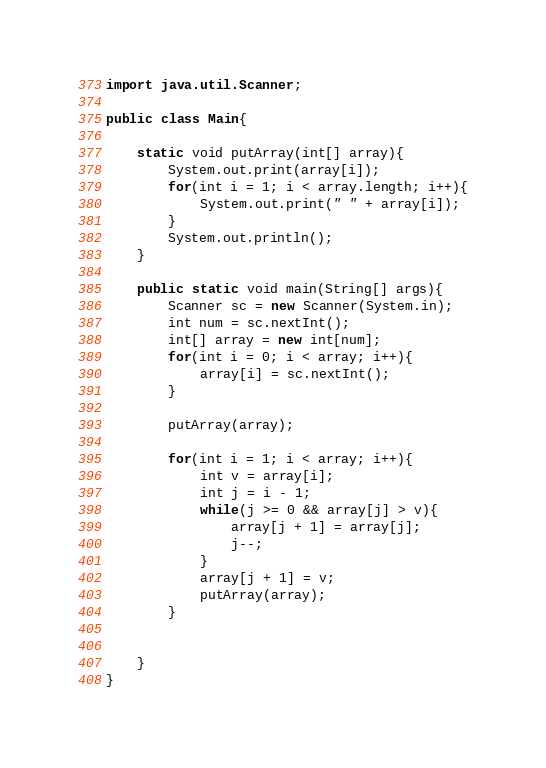<code> <loc_0><loc_0><loc_500><loc_500><_Java_>import java.util.Scanner;

public class Main{
    
    static void putArray(int[] array){
        System.out.print(array[i]);
        for(int i = 1; i < array.length; i++){
            System.out.print(" " + array[i]);
        }
        System.out.println();
    }
    
    public static void main(String[] args){
        Scanner sc = new Scanner(System.in);
        int num = sc.nextInt();
        int[] array = new int[num];
        for(int i = 0; i < array; i++){
            array[i] = sc.nextInt();
        }
        
        putArray(array);
        
        for(int i = 1; i < array; i++){
            int v = array[i];
            int j = i - 1;
            while(j >= 0 && array[j] > v){
                array[j + 1] = array[j];
                j--;
            }
            array[j + 1] = v;
            putArray(array);
        }
        
        
    }
}
</code> 